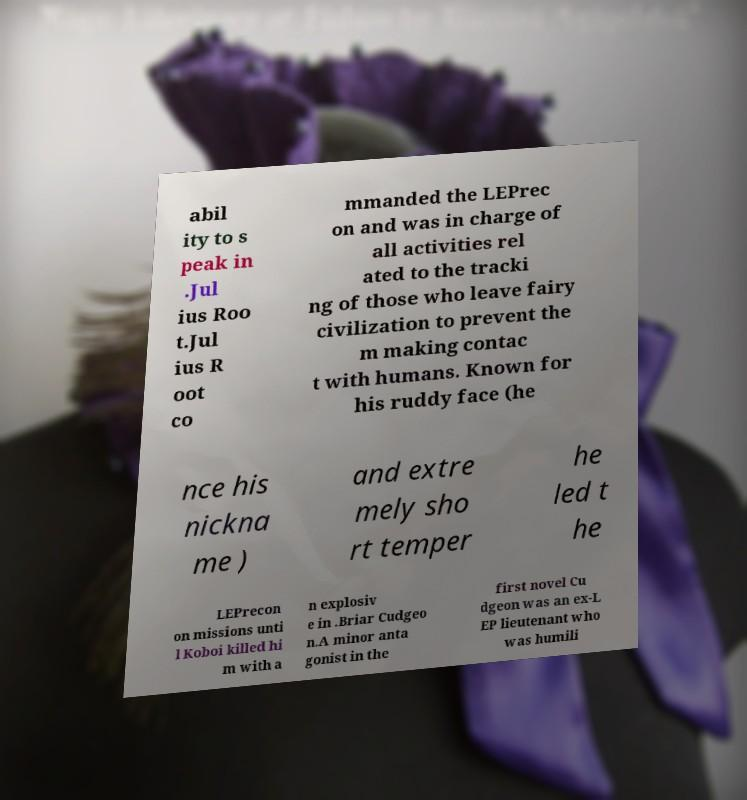Could you assist in decoding the text presented in this image and type it out clearly? abil ity to s peak in .Jul ius Roo t.Jul ius R oot co mmanded the LEPrec on and was in charge of all activities rel ated to the tracki ng of those who leave fairy civilization to prevent the m making contac t with humans. Known for his ruddy face (he nce his nickna me ) and extre mely sho rt temper he led t he LEPrecon on missions unti l Koboi killed hi m with a n explosiv e in .Briar Cudgeo n.A minor anta gonist in the first novel Cu dgeon was an ex-L EP lieutenant who was humili 